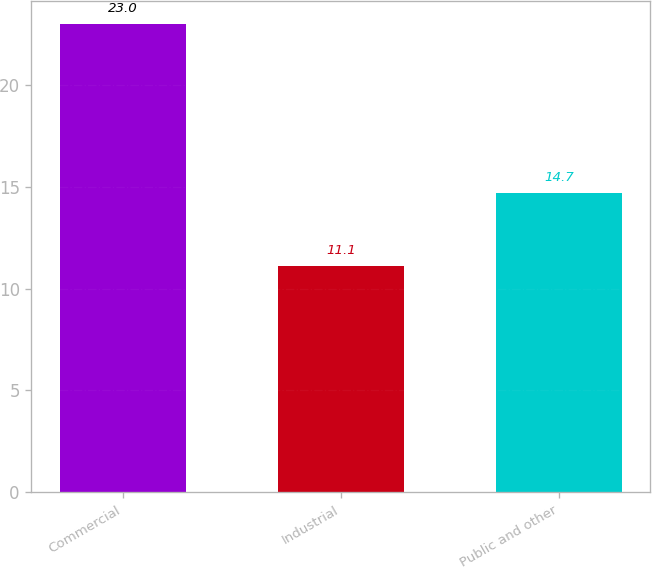<chart> <loc_0><loc_0><loc_500><loc_500><bar_chart><fcel>Commercial<fcel>Industrial<fcel>Public and other<nl><fcel>23<fcel>11.1<fcel>14.7<nl></chart> 